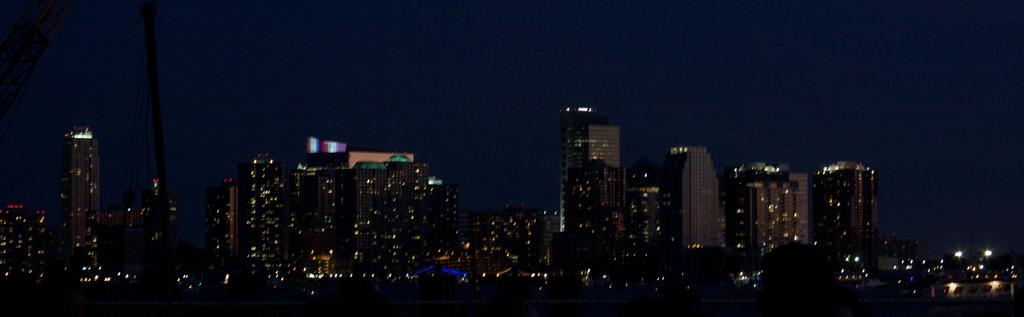What type of structures can be seen in the image? There are buildings in the image. What can be found on the left side of the image? There are metal rods on the left side of the image. What type of print can be seen on the tongue of the person in the image? There is no person present in the image, and therefore no tongue or print on a tongue can be observed. 